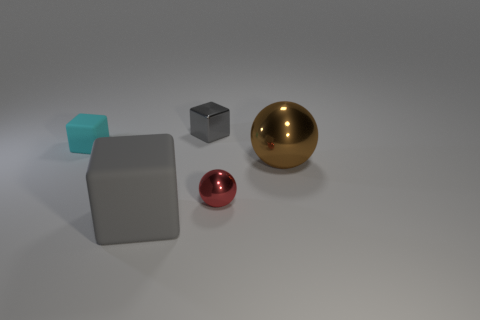Subtract all tiny rubber blocks. How many blocks are left? 2 Add 1 small red matte balls. How many objects exist? 6 Subtract all cyan blocks. How many blocks are left? 2 Subtract all spheres. How many objects are left? 3 Subtract 1 cubes. How many cubes are left? 2 Subtract all green cylinders. How many gray blocks are left? 2 Subtract all gray cubes. Subtract all red spheres. How many cubes are left? 1 Subtract all big brown balls. Subtract all tiny rubber things. How many objects are left? 3 Add 4 brown objects. How many brown objects are left? 5 Add 1 tiny red blocks. How many tiny red blocks exist? 1 